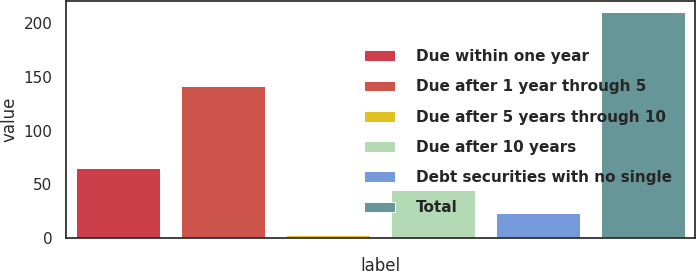Convert chart to OTSL. <chart><loc_0><loc_0><loc_500><loc_500><bar_chart><fcel>Due within one year<fcel>Due after 1 year through 5<fcel>Due after 5 years through 10<fcel>Due after 10 years<fcel>Debt securities with no single<fcel>Total<nl><fcel>65.1<fcel>141<fcel>3<fcel>44.4<fcel>23.7<fcel>210<nl></chart> 